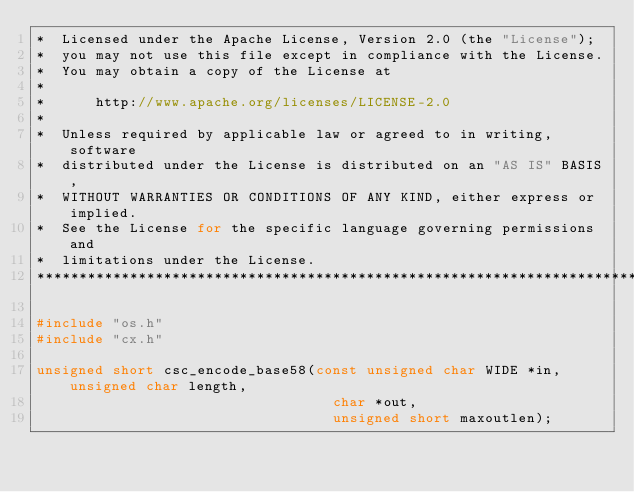<code> <loc_0><loc_0><loc_500><loc_500><_C_>*  Licensed under the Apache License, Version 2.0 (the "License");
*  you may not use this file except in compliance with the License.
*  You may obtain a copy of the License at
*
*      http://www.apache.org/licenses/LICENSE-2.0
*
*  Unless required by applicable law or agreed to in writing, software
*  distributed under the License is distributed on an "AS IS" BASIS,
*  WITHOUT WARRANTIES OR CONDITIONS OF ANY KIND, either express or implied.
*  See the License for the specific language governing permissions and
*  limitations under the License.
********************************************************************************/

#include "os.h"
#include "cx.h"

unsigned short csc_encode_base58(const unsigned char WIDE *in, unsigned char length,
                                   char *out,
                                   unsigned short maxoutlen);
</code> 